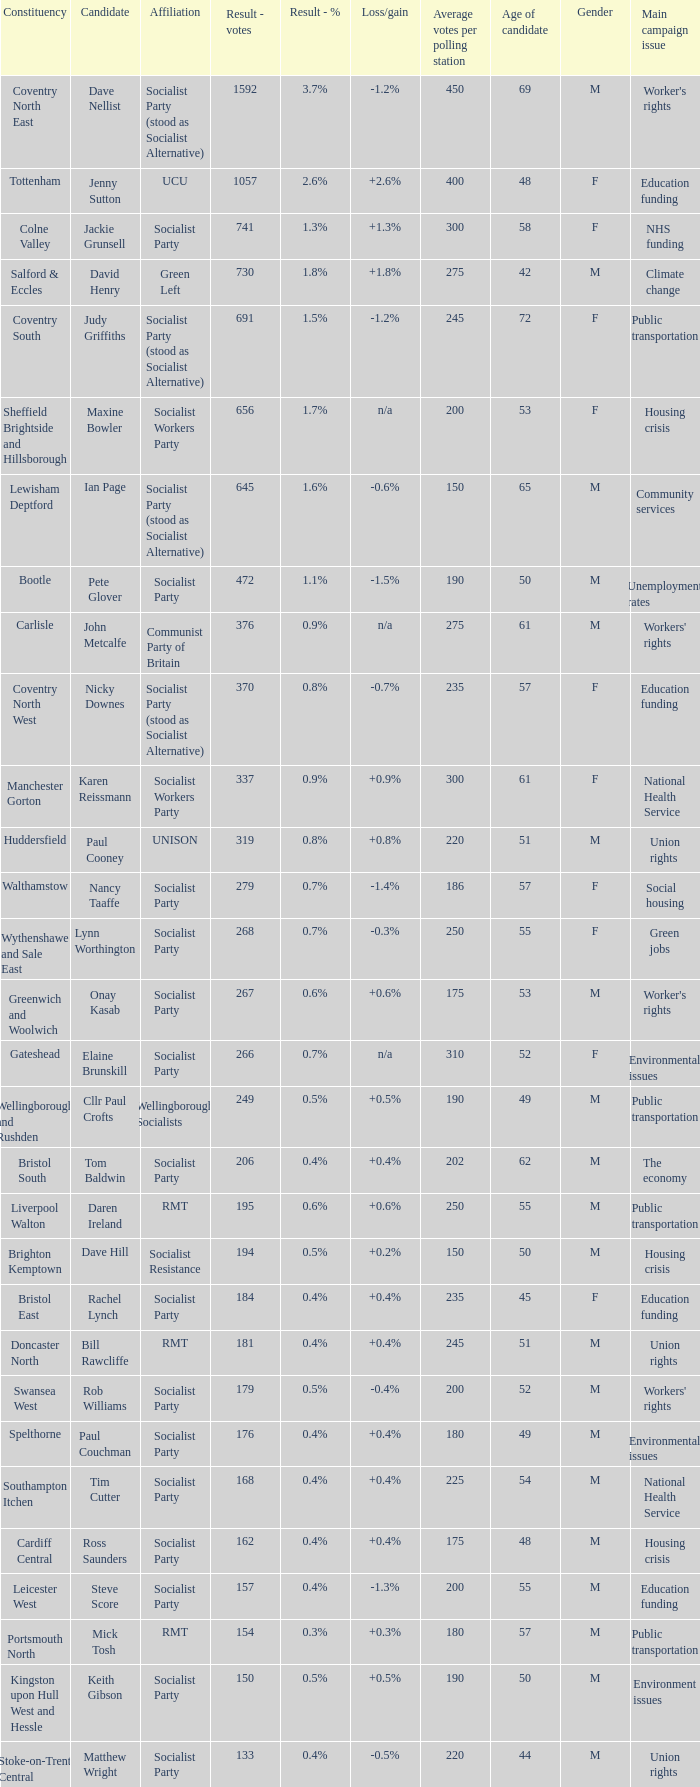What is the largest vote result if loss/gain is -0.5%? 133.0. 